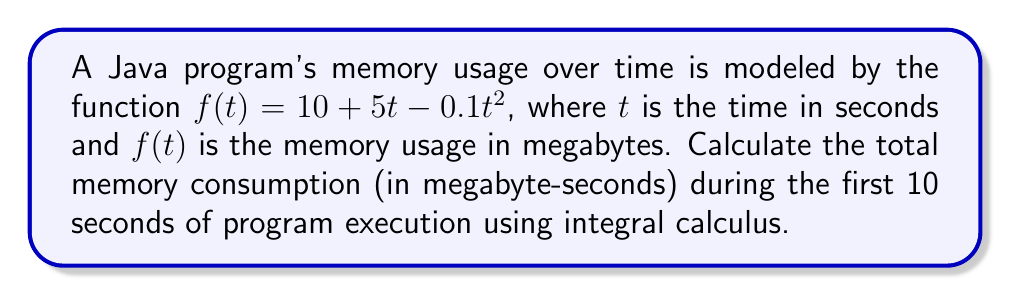Give your solution to this math problem. To calculate the total memory consumption, we need to find the area under the curve $f(t) = 10 + 5t - 0.1t^2$ from $t=0$ to $t=10$. This can be done using a definite integral:

1. Set up the integral:
   $$\int_0^{10} (10 + 5t - 0.1t^2) dt$$

2. Integrate the function:
   $$\Big[10t + \frac{5t^2}{2} - \frac{0.1t^3}{3}\Big]_0^{10}$$

3. Evaluate the integral at the upper and lower bounds:
   $$\Big(10(10) + \frac{5(10^2)}{2} - \frac{0.1(10^3)}{3}\Big) - \Big(10(0) + \frac{5(0^2)}{2} - \frac{0.1(0^3)}{3}\Big)$$

4. Simplify:
   $$\Big(100 + 250 - \frac{100}{3}\Big) - 0$$
   $$= 350 - \frac{100}{3}$$
   $$= \frac{1050 - 100}{3}$$
   $$= \frac{950}{3}$$
   $$\approx 316.67$$

The result is in megabyte-seconds, representing the total memory consumption over the 10-second period.
Answer: $\frac{950}{3}$ megabyte-seconds 